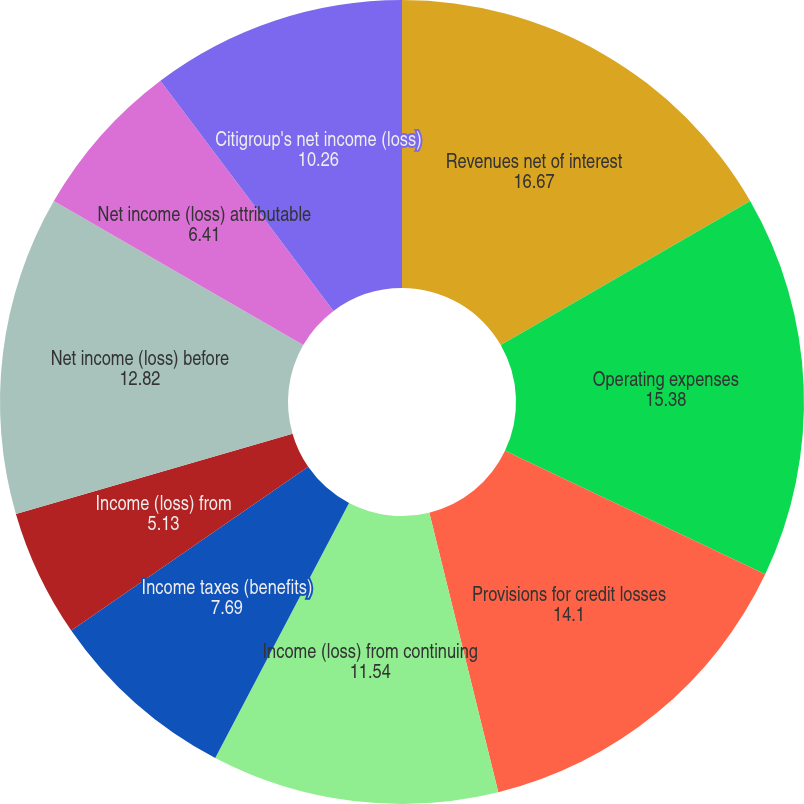Convert chart to OTSL. <chart><loc_0><loc_0><loc_500><loc_500><pie_chart><fcel>Revenues net of interest<fcel>Operating expenses<fcel>Provisions for credit losses<fcel>Income (loss) from continuing<fcel>Income taxes (benefits)<fcel>Income (loss) from<fcel>Net income (loss) before<fcel>Net income (loss) attributable<fcel>Citigroup's net income (loss)<nl><fcel>16.67%<fcel>15.38%<fcel>14.1%<fcel>11.54%<fcel>7.69%<fcel>5.13%<fcel>12.82%<fcel>6.41%<fcel>10.26%<nl></chart> 